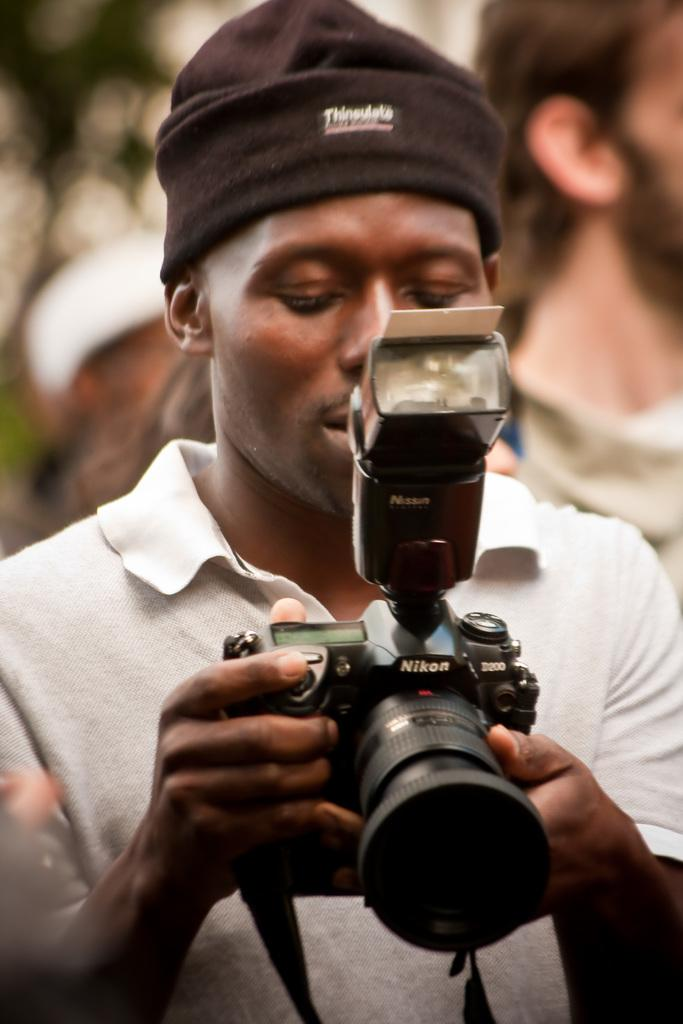<image>
Relay a brief, clear account of the picture shown. a man holding onto a camera that is from Nikon 